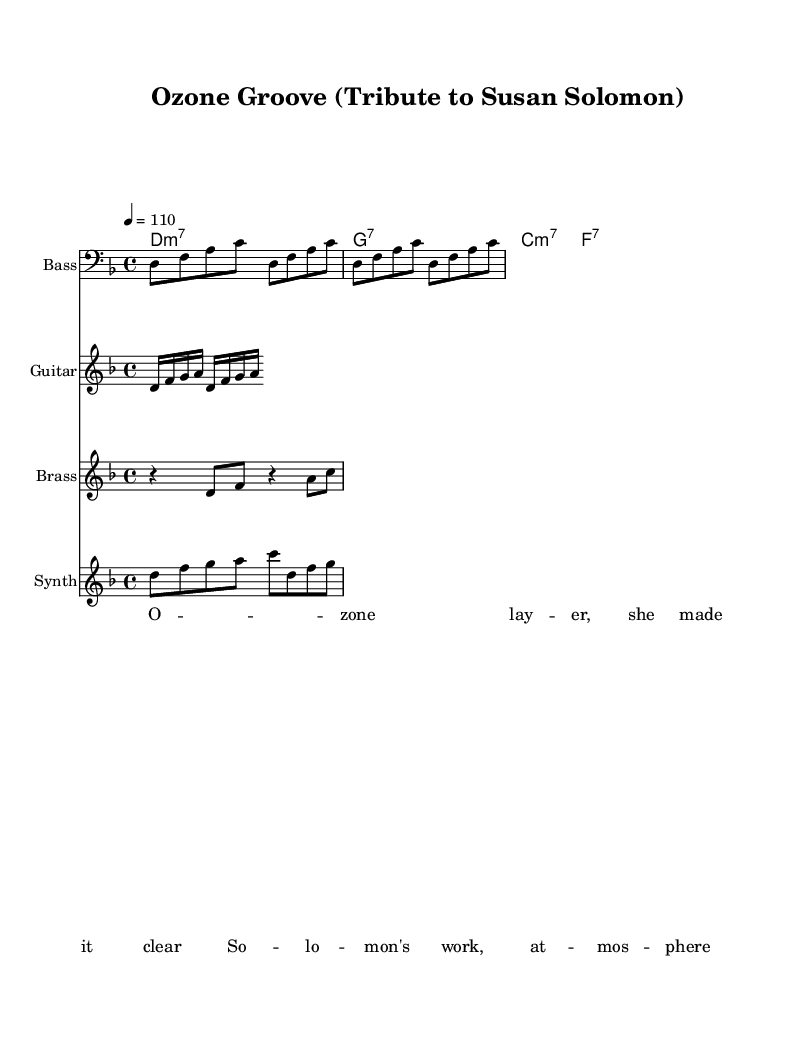What is the key signature of the piece? The key signature indicates that the piece is in D minor, which contains one flat (B flat). This can be inferred from the global settings in the code.
Answer: D minor What is the time signature indicated in the sheet music? The time signature is expressed in the global section of the code as 4/4, which means there are four beats in a measure and the quarter note receives one beat.
Answer: 4/4 What is the tempo marking of the piece? The tempo marking in the global section indicates a tempo of 110 beats per minute, which guides performers on how fast to play the music.
Answer: 110 How many measures are in the bass line? The bass line is repeated four times in the provided code, which suggests that the complete bass line spans four measures, as indicated by the repetition command.
Answer: 4 What type of ensemble is indicated by the instrument names? The ensemble includes a bass, guitar, brass, and synth, which are listed in the individual staff sections. This is characteristic of a funk setup that blends these instruments for a groove.
Answer: Funk ensemble What is the highest note in the synth melody? The synth melody includes a D, which is two octaves above middle C, and is noted as the highest note in the provided melody line. This reflects a common range for synth instruments in funk music.
Answer: D What lyrical theme is presented in the lyrics? The lyrics focus on ozone and climate science, specifically referencing Susan Solomon's work. This ties the musical tribute to environmental themes, celebrating influential climate scientists.
Answer: Climate science 